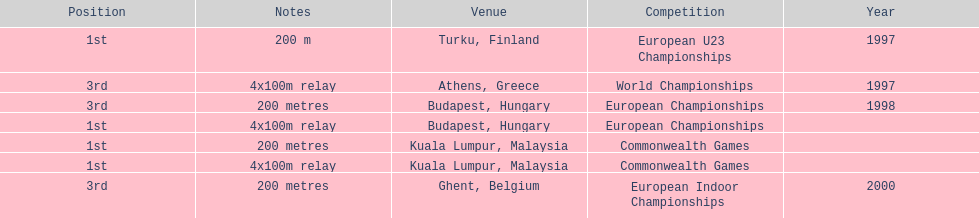How many total years did golding compete? 3. 